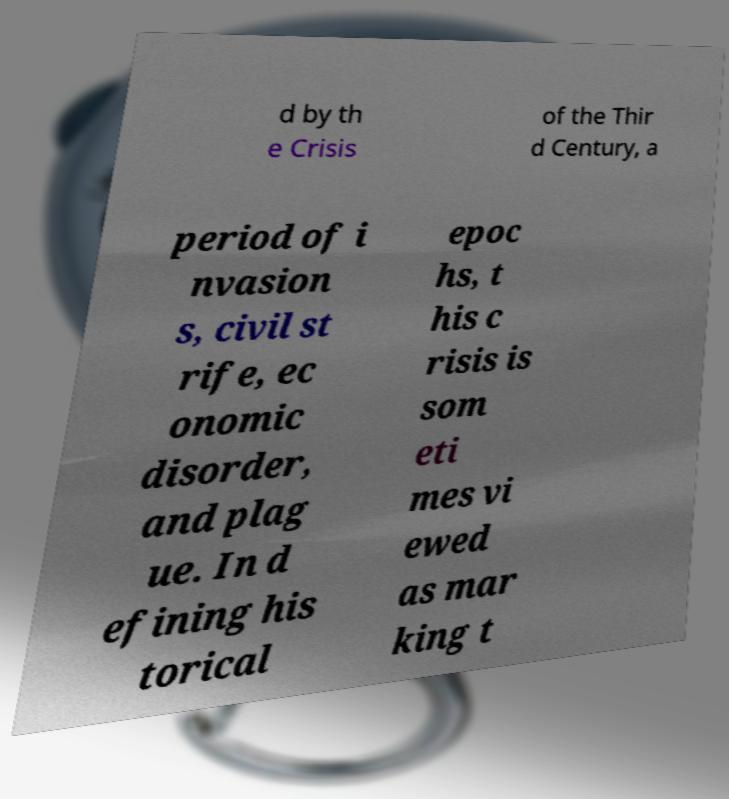Please read and relay the text visible in this image. What does it say? d by th e Crisis of the Thir d Century, a period of i nvasion s, civil st rife, ec onomic disorder, and plag ue. In d efining his torical epoc hs, t his c risis is som eti mes vi ewed as mar king t 